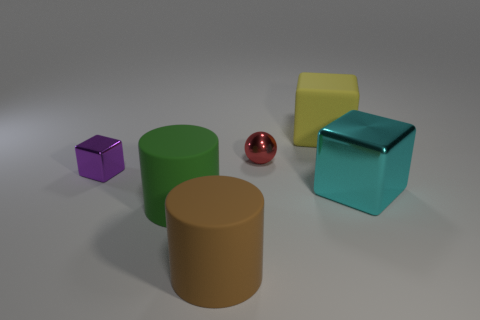Add 3 large yellow blocks. How many objects exist? 9 Subtract all cylinders. How many objects are left? 4 Add 1 matte things. How many matte things exist? 4 Subtract 1 brown cylinders. How many objects are left? 5 Subtract all large cyan balls. Subtract all cylinders. How many objects are left? 4 Add 4 tiny metallic cubes. How many tiny metallic cubes are left? 5 